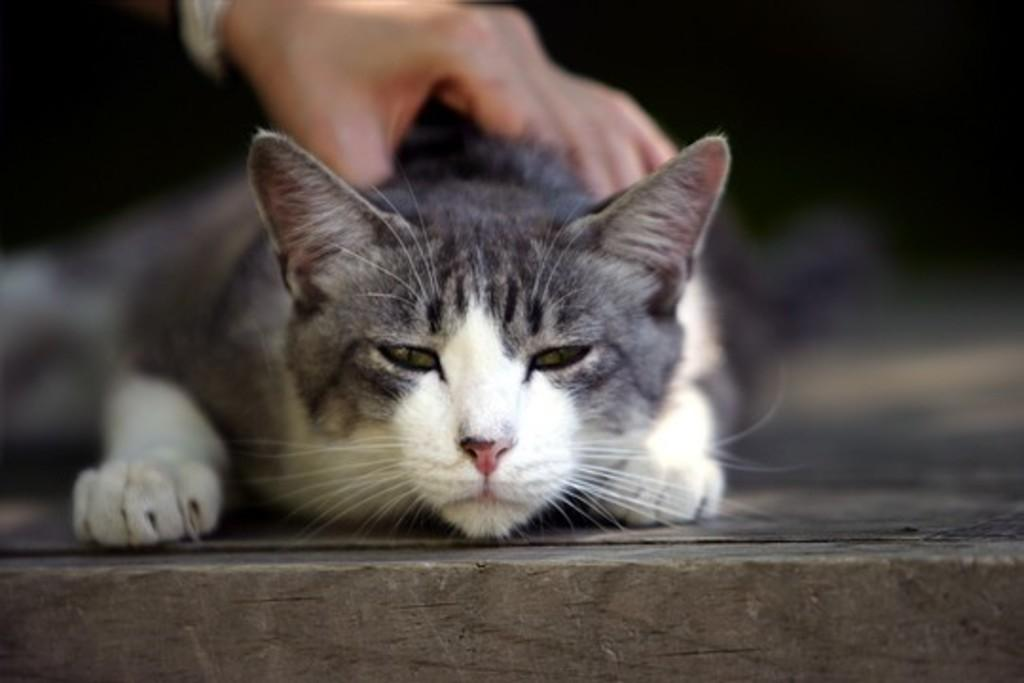What animal is present in the image? There is a cat in the image. What type of surface is the cat on? The cat is on a wooden surface. Is there any interaction between a person and the cat in the image? Yes, there is a hand on the cat at the top side. What type of prison can be seen in the background of the image? There is no prison present in the image; it features a cat on a wooden surface with a hand on its top side. What is the color of the copper in the image? There is no copper present in the image. 